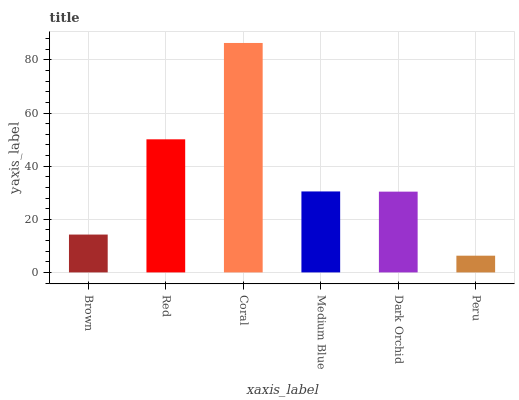Is Peru the minimum?
Answer yes or no. Yes. Is Coral the maximum?
Answer yes or no. Yes. Is Red the minimum?
Answer yes or no. No. Is Red the maximum?
Answer yes or no. No. Is Red greater than Brown?
Answer yes or no. Yes. Is Brown less than Red?
Answer yes or no. Yes. Is Brown greater than Red?
Answer yes or no. No. Is Red less than Brown?
Answer yes or no. No. Is Medium Blue the high median?
Answer yes or no. Yes. Is Dark Orchid the low median?
Answer yes or no. Yes. Is Coral the high median?
Answer yes or no. No. Is Peru the low median?
Answer yes or no. No. 